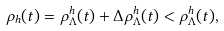Convert formula to latex. <formula><loc_0><loc_0><loc_500><loc_500>\rho _ { h } ( t ) = \rho ^ { h } _ { \Lambda } ( t ) + \Delta \rho ^ { h } _ { \Lambda } ( t ) < \rho ^ { h } _ { \Lambda } ( t ) ,</formula> 